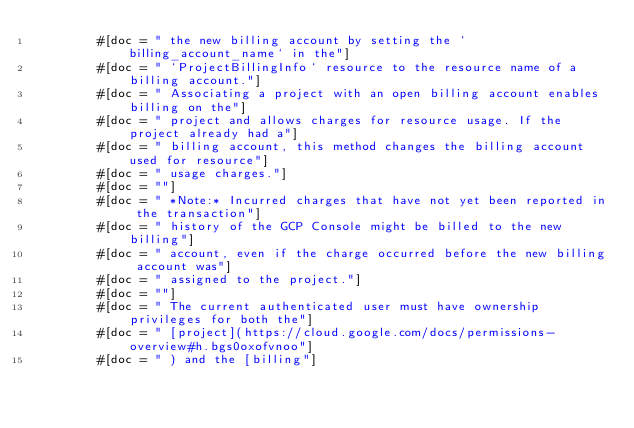<code> <loc_0><loc_0><loc_500><loc_500><_Rust_>        #[doc = " the new billing account by setting the `billing_account_name` in the"]
        #[doc = " `ProjectBillingInfo` resource to the resource name of a billing account."]
        #[doc = " Associating a project with an open billing account enables billing on the"]
        #[doc = " project and allows charges for resource usage. If the project already had a"]
        #[doc = " billing account, this method changes the billing account used for resource"]
        #[doc = " usage charges."]
        #[doc = ""]
        #[doc = " *Note:* Incurred charges that have not yet been reported in the transaction"]
        #[doc = " history of the GCP Console might be billed to the new billing"]
        #[doc = " account, even if the charge occurred before the new billing account was"]
        #[doc = " assigned to the project."]
        #[doc = ""]
        #[doc = " The current authenticated user must have ownership privileges for both the"]
        #[doc = " [project](https://cloud.google.com/docs/permissions-overview#h.bgs0oxofvnoo"]
        #[doc = " ) and the [billing"]</code> 